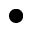<formula> <loc_0><loc_0><loc_500><loc_500>\bullet</formula> 